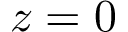Convert formula to latex. <formula><loc_0><loc_0><loc_500><loc_500>z = 0</formula> 